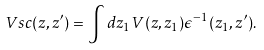Convert formula to latex. <formula><loc_0><loc_0><loc_500><loc_500>\ V s c ( z , z ^ { \prime } ) = \int d z _ { 1 } V ( z , z _ { 1 } ) \epsilon ^ { - 1 } ( z _ { 1 } , z ^ { \prime } ) .</formula> 